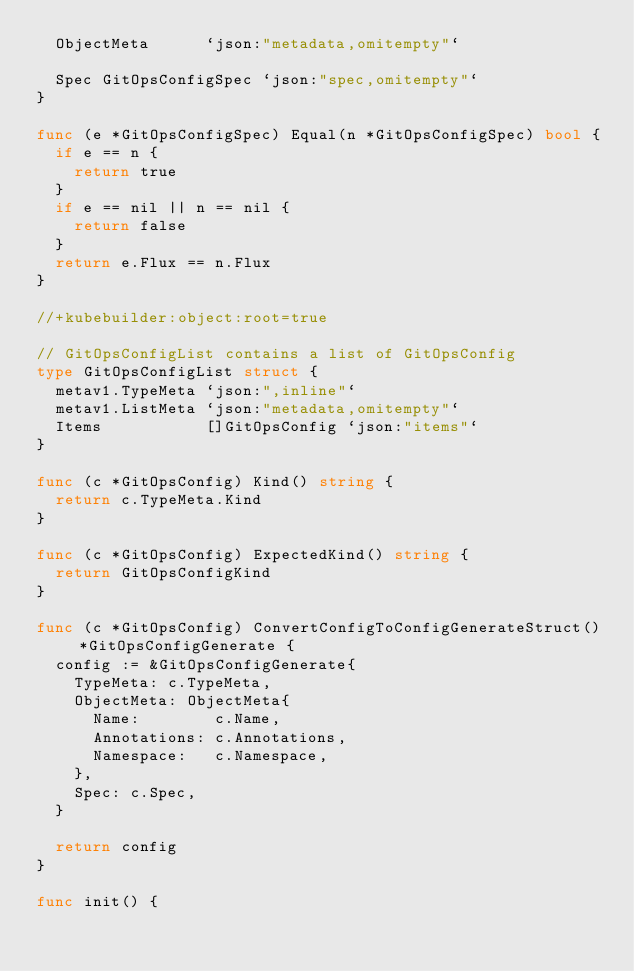<code> <loc_0><loc_0><loc_500><loc_500><_Go_>	ObjectMeta      `json:"metadata,omitempty"`

	Spec GitOpsConfigSpec `json:"spec,omitempty"`
}

func (e *GitOpsConfigSpec) Equal(n *GitOpsConfigSpec) bool {
	if e == n {
		return true
	}
	if e == nil || n == nil {
		return false
	}
	return e.Flux == n.Flux
}

//+kubebuilder:object:root=true

// GitOpsConfigList contains a list of GitOpsConfig
type GitOpsConfigList struct {
	metav1.TypeMeta `json:",inline"`
	metav1.ListMeta `json:"metadata,omitempty"`
	Items           []GitOpsConfig `json:"items"`
}

func (c *GitOpsConfig) Kind() string {
	return c.TypeMeta.Kind
}

func (c *GitOpsConfig) ExpectedKind() string {
	return GitOpsConfigKind
}

func (c *GitOpsConfig) ConvertConfigToConfigGenerateStruct() *GitOpsConfigGenerate {
	config := &GitOpsConfigGenerate{
		TypeMeta: c.TypeMeta,
		ObjectMeta: ObjectMeta{
			Name:        c.Name,
			Annotations: c.Annotations,
			Namespace:   c.Namespace,
		},
		Spec: c.Spec,
	}

	return config
}

func init() {</code> 